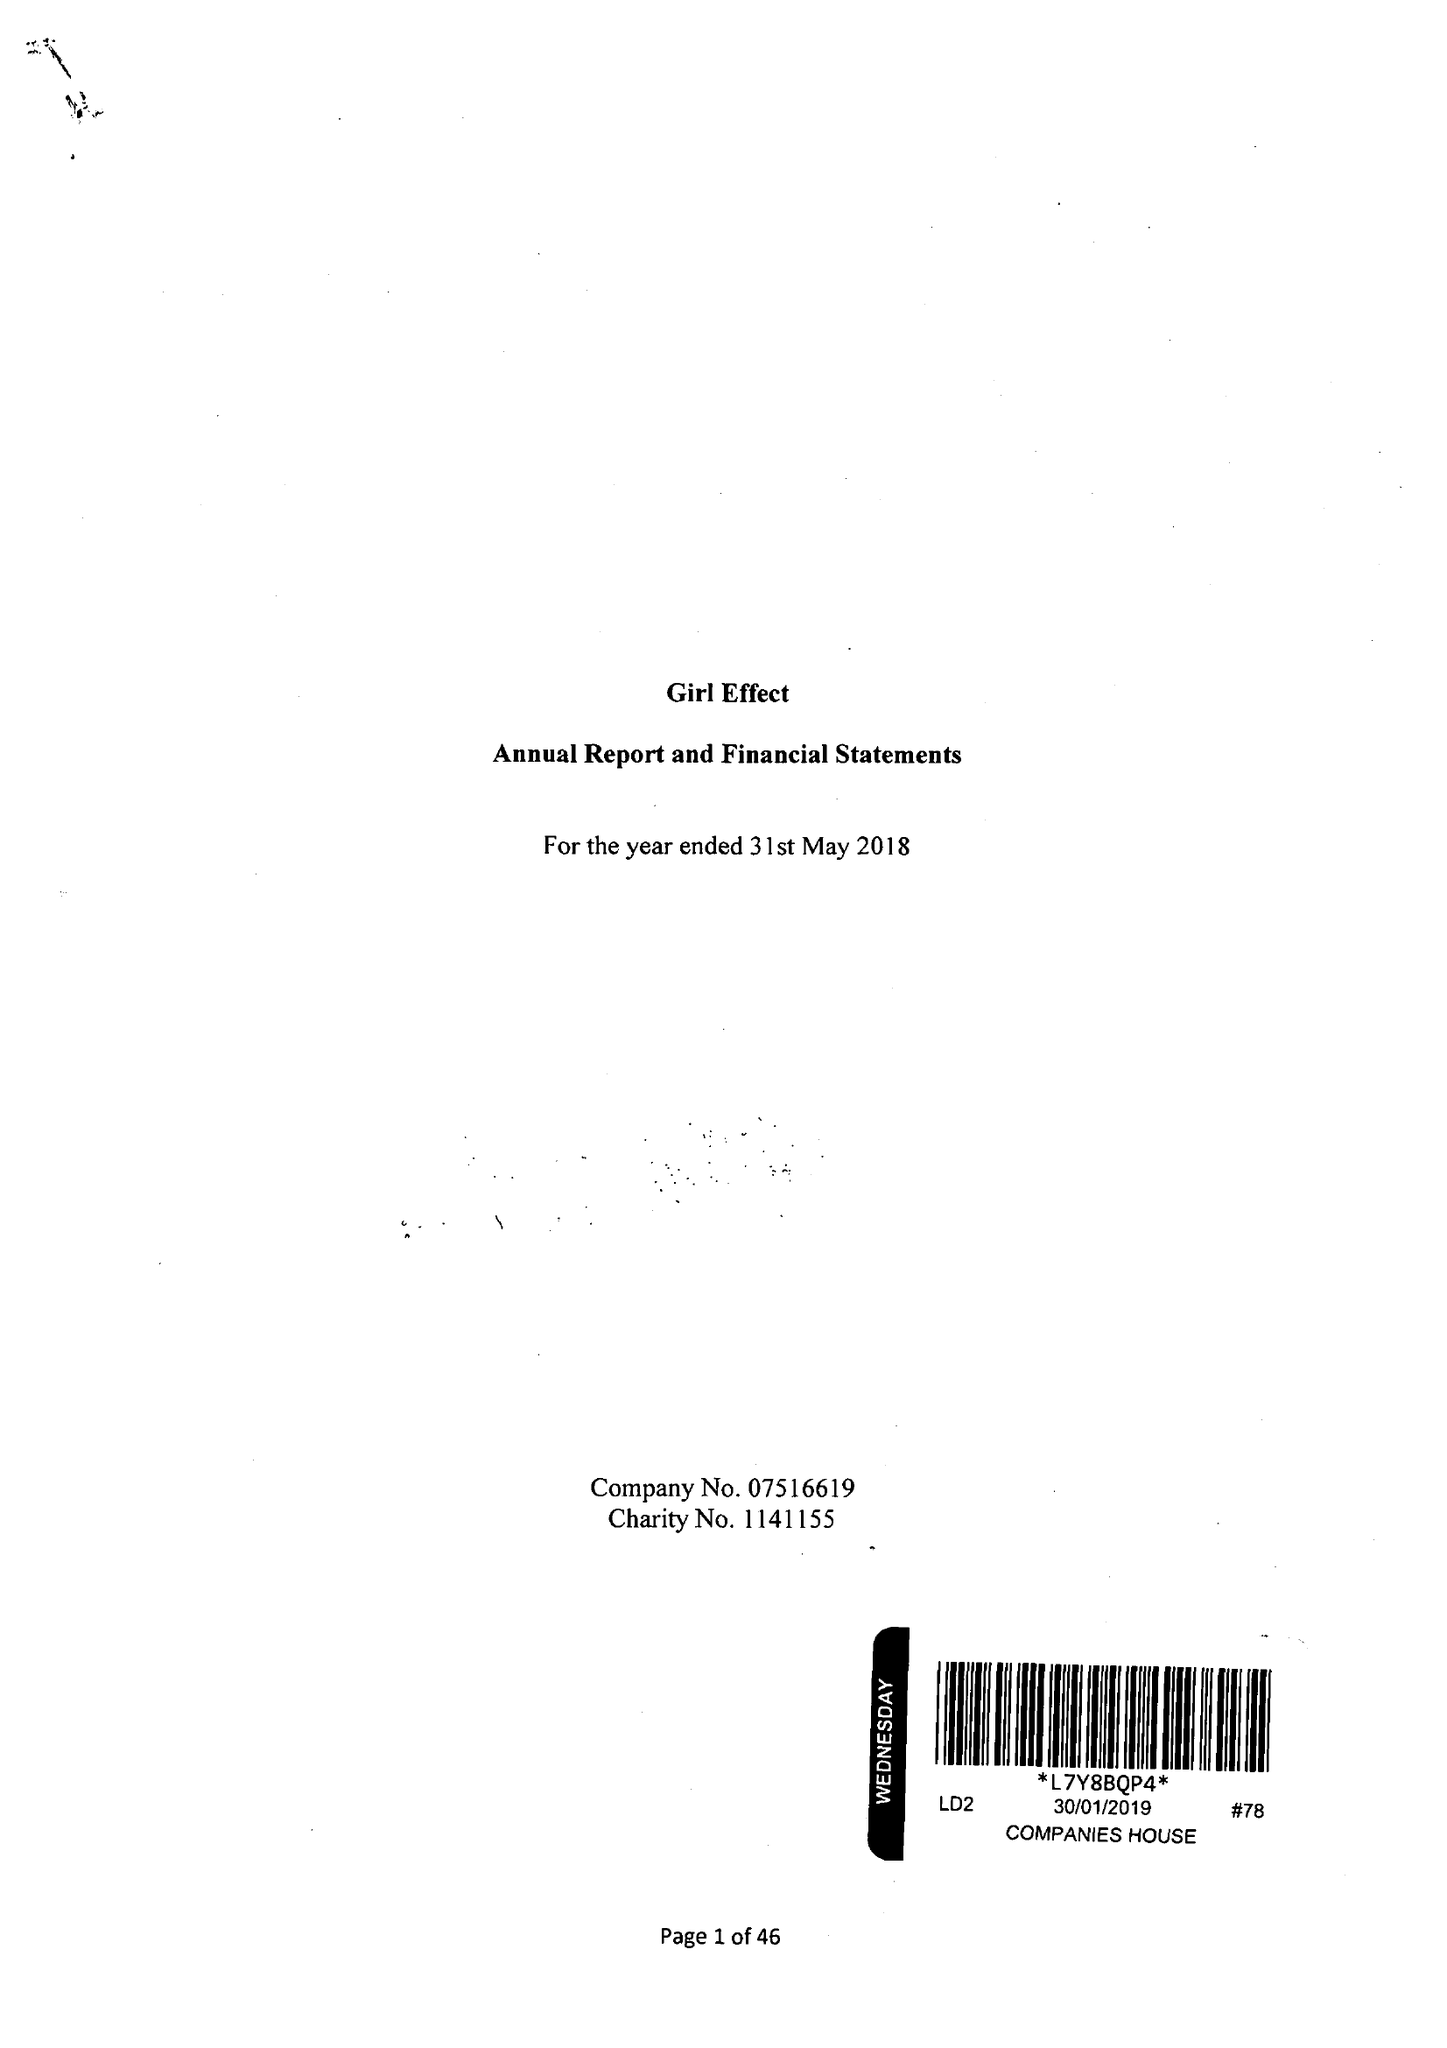What is the value for the address__street_line?
Answer the question using a single word or phrase. 17 BROADWICK STREET 